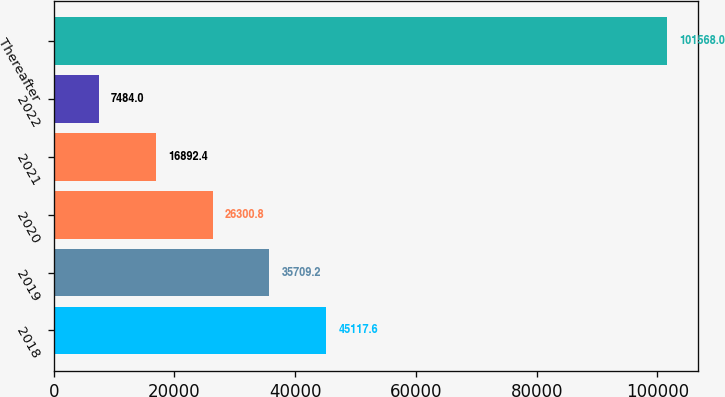Convert chart. <chart><loc_0><loc_0><loc_500><loc_500><bar_chart><fcel>2018<fcel>2019<fcel>2020<fcel>2021<fcel>2022<fcel>Thereafter<nl><fcel>45117.6<fcel>35709.2<fcel>26300.8<fcel>16892.4<fcel>7484<fcel>101568<nl></chart> 